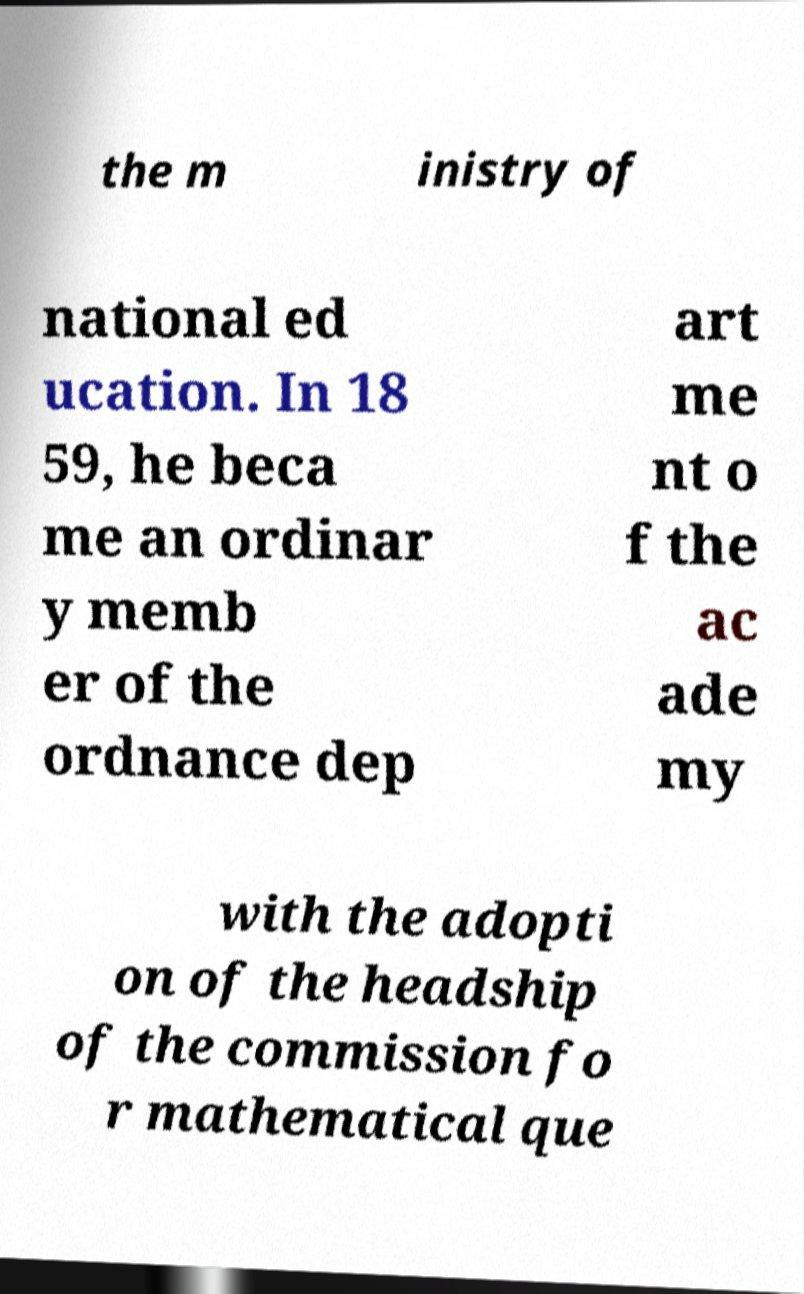What messages or text are displayed in this image? I need them in a readable, typed format. the m inistry of national ed ucation. In 18 59, he beca me an ordinar y memb er of the ordnance dep art me nt o f the ac ade my with the adopti on of the headship of the commission fo r mathematical que 